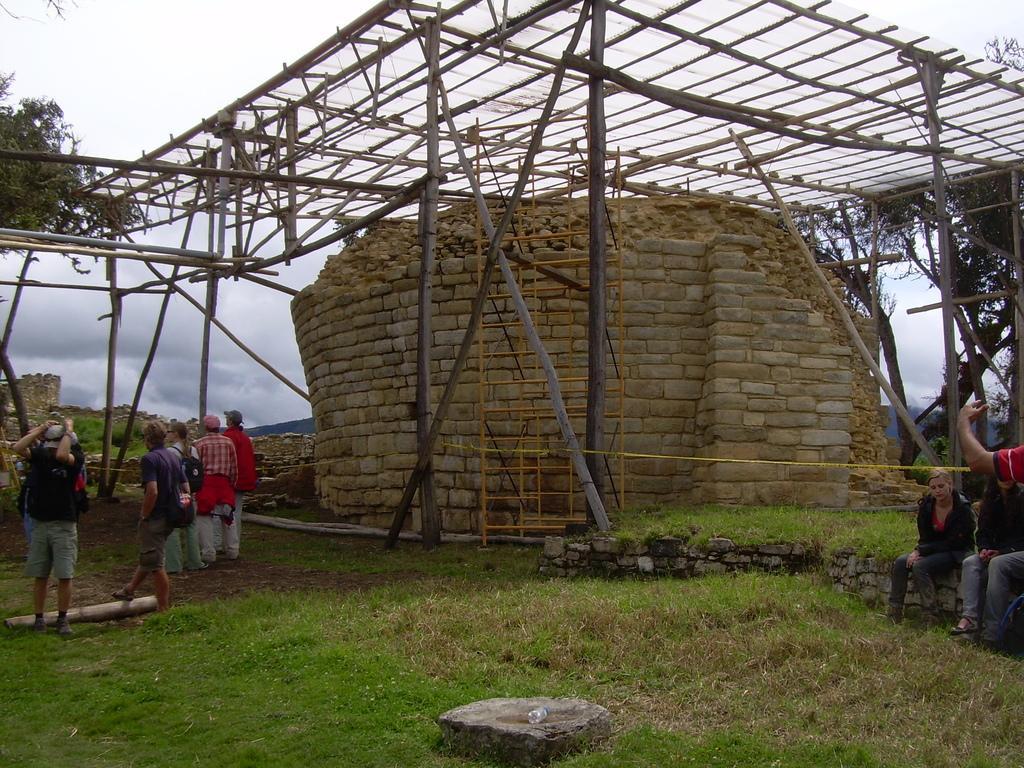Can you describe this image briefly? In this image we can see a wooden roof and brick wall. Right and left sides of the image people are sitting and standing. And trees are present. The sky is full of clouds. 